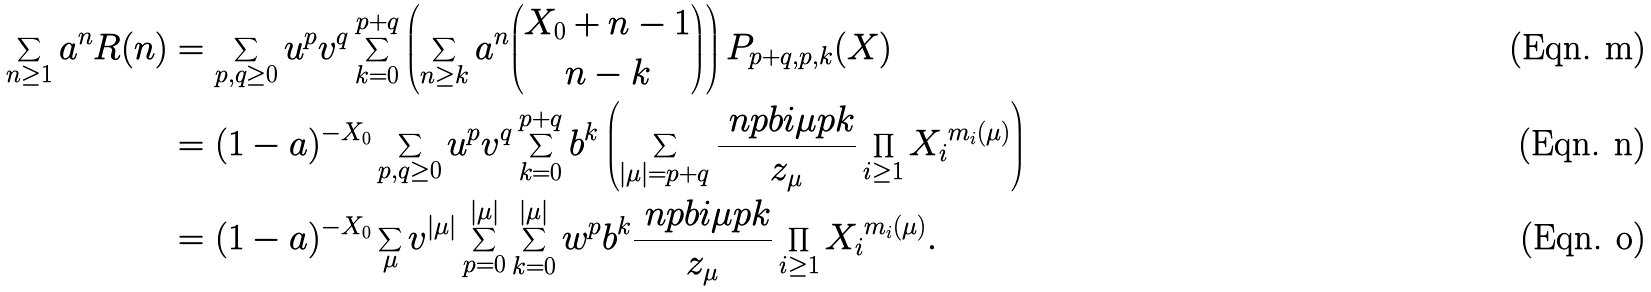Convert formula to latex. <formula><loc_0><loc_0><loc_500><loc_500>\sum _ { n \geq 1 } a ^ { n } R ( n ) & = \sum _ { p , q \geq 0 } u ^ { p } v ^ { q } \sum _ { k = 0 } ^ { p + q } \left ( \sum _ { n \geq k } a ^ { n } \binom { X _ { 0 } + n - 1 } { n - k } \right ) P _ { p + q , p , k } ( X ) \\ & = ( 1 - a ) ^ { - X _ { 0 } } \sum _ { p , q \geq 0 } u ^ { p } v ^ { q } \sum _ { k = 0 } ^ { p + q } b ^ { k } \left ( \sum _ { | \mu | = p + q } \frac { \ n p b i { \mu } { p } { k } } { z _ { \mu } } \prod _ { i \geq 1 } { X _ { i } } ^ { m _ { i } ( \mu ) } \right ) \\ & = ( 1 - a ) ^ { - X _ { 0 } } \sum _ { \mu } v ^ { | \mu | } \sum _ { p = 0 } ^ { | \mu | } \sum _ { k = 0 } ^ { | \mu | } w ^ { p } b ^ { k } \frac { \ n p b i { \mu } { p } { k } } { z _ { \mu } } \prod _ { i \geq 1 } { X _ { i } } ^ { m _ { i } ( \mu ) } .</formula> 